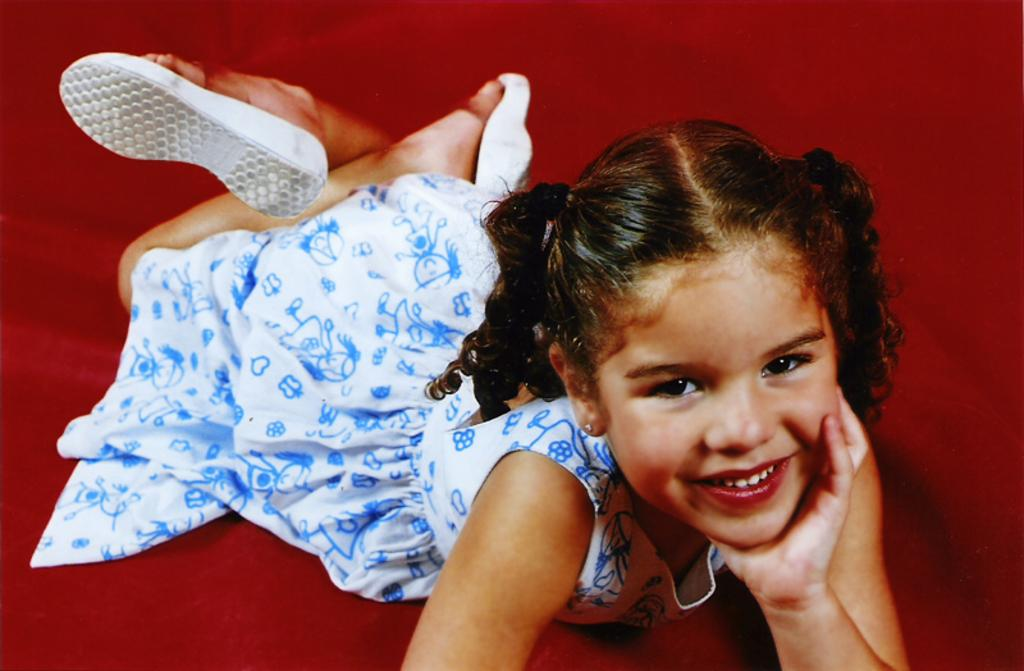Who is the main subject in the image? There is a girl in the image. What is the girl doing in the image? The girl is lying on a red cloth. What is the girl's facial expression in the image? The girl is smiling. What is the girl wearing in the image? The girl is wearing a white and blue color dress and white color footwear. What type of laborer can be seen working on the railway in the image? There is no laborer or railway present in the image; it features a girl lying on a red cloth. 